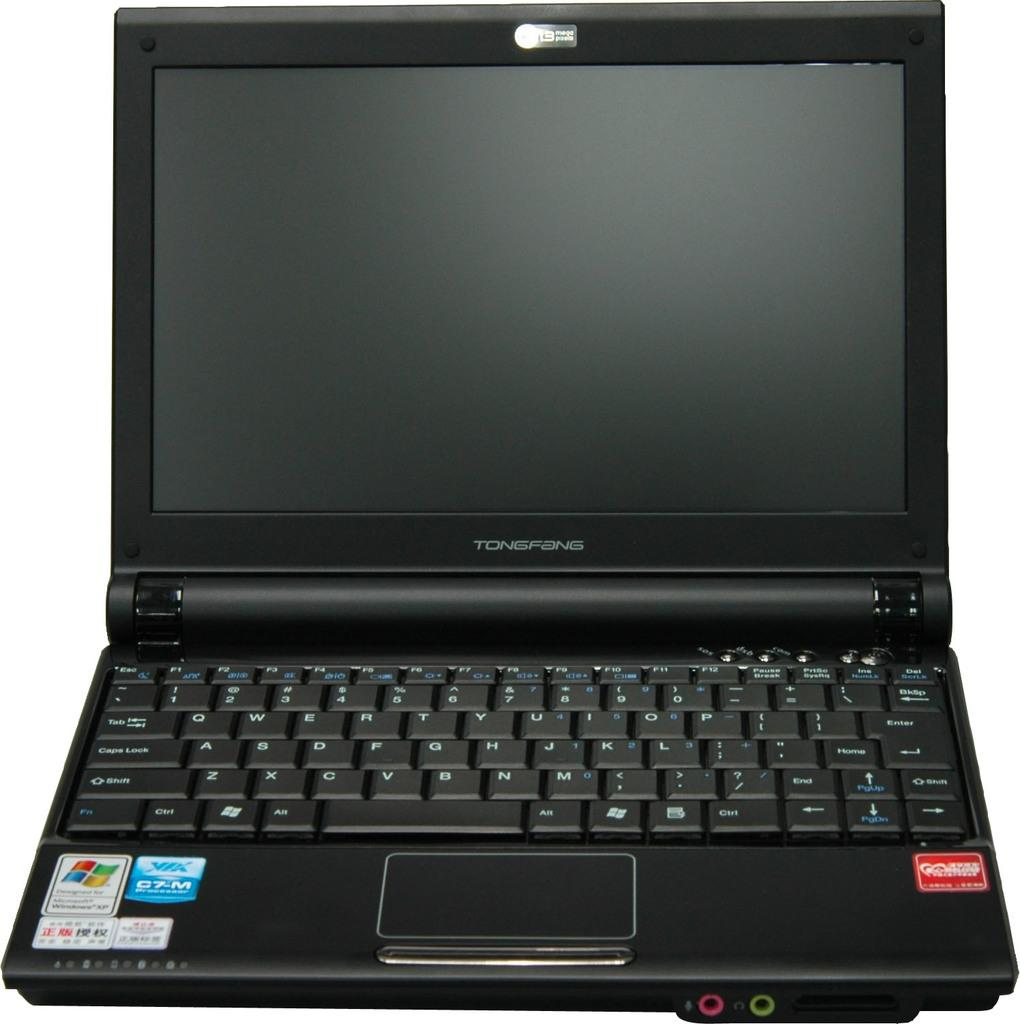<image>
Relay a brief, clear account of the picture shown. a tongfang keyboard that has many keys on it 